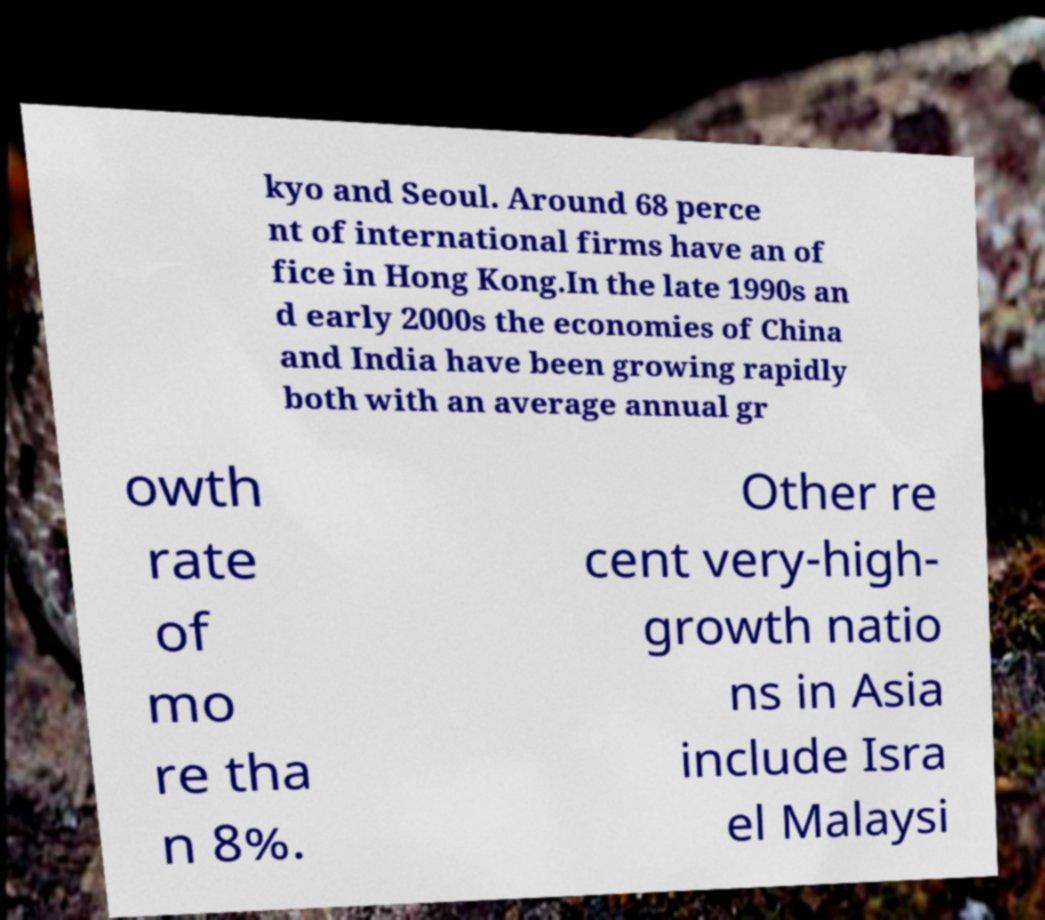Can you read and provide the text displayed in the image?This photo seems to have some interesting text. Can you extract and type it out for me? kyo and Seoul. Around 68 perce nt of international firms have an of fice in Hong Kong.In the late 1990s an d early 2000s the economies of China and India have been growing rapidly both with an average annual gr owth rate of mo re tha n 8%. Other re cent very-high- growth natio ns in Asia include Isra el Malaysi 